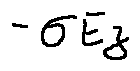Convert formula to latex. <formula><loc_0><loc_0><loc_500><loc_500>- \sigma E z</formula> 